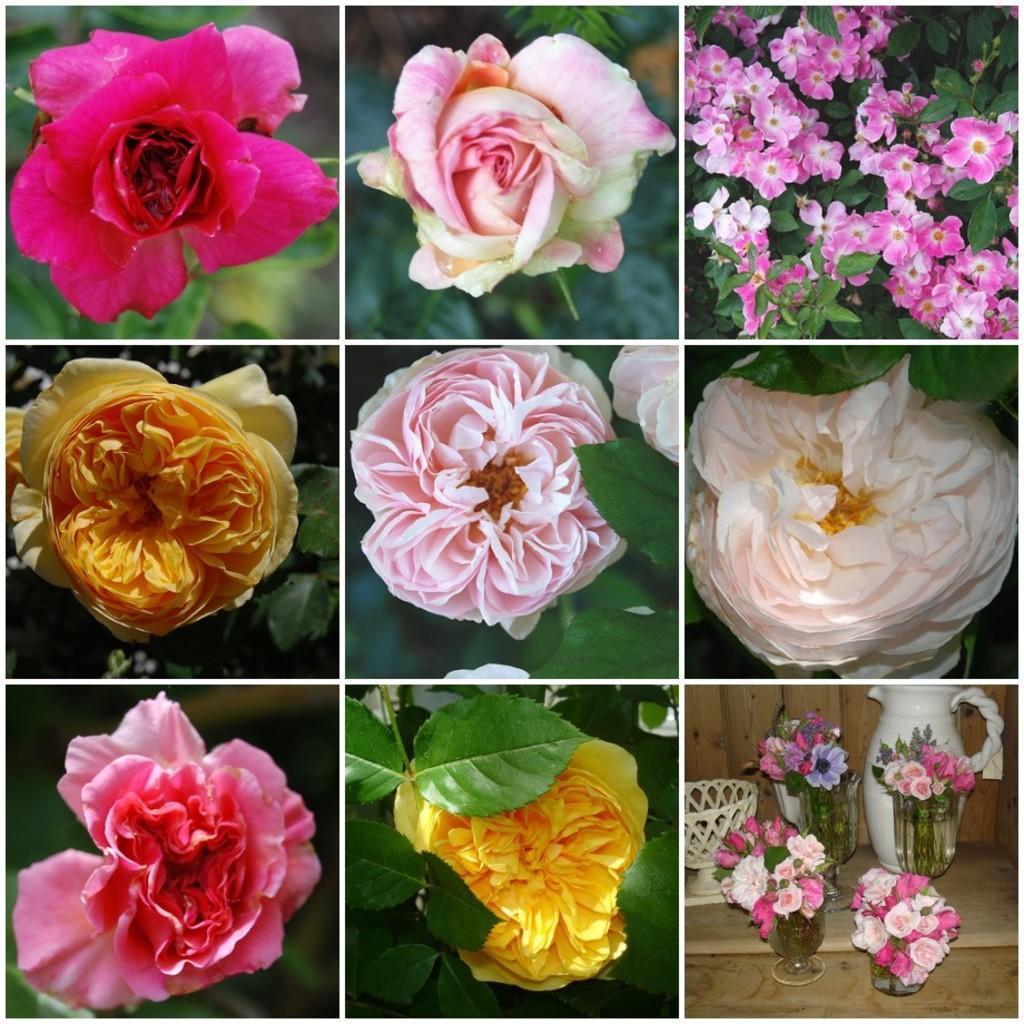How would you summarize this image in a sentence or two? In this image, at the right side bottom, we can see some flower pot with flowers and a jar. On the right side, we can see some flowers. In the middle of the image, we can see some flowers with leaves. On the left side, we can also see flowers with green leaves. 